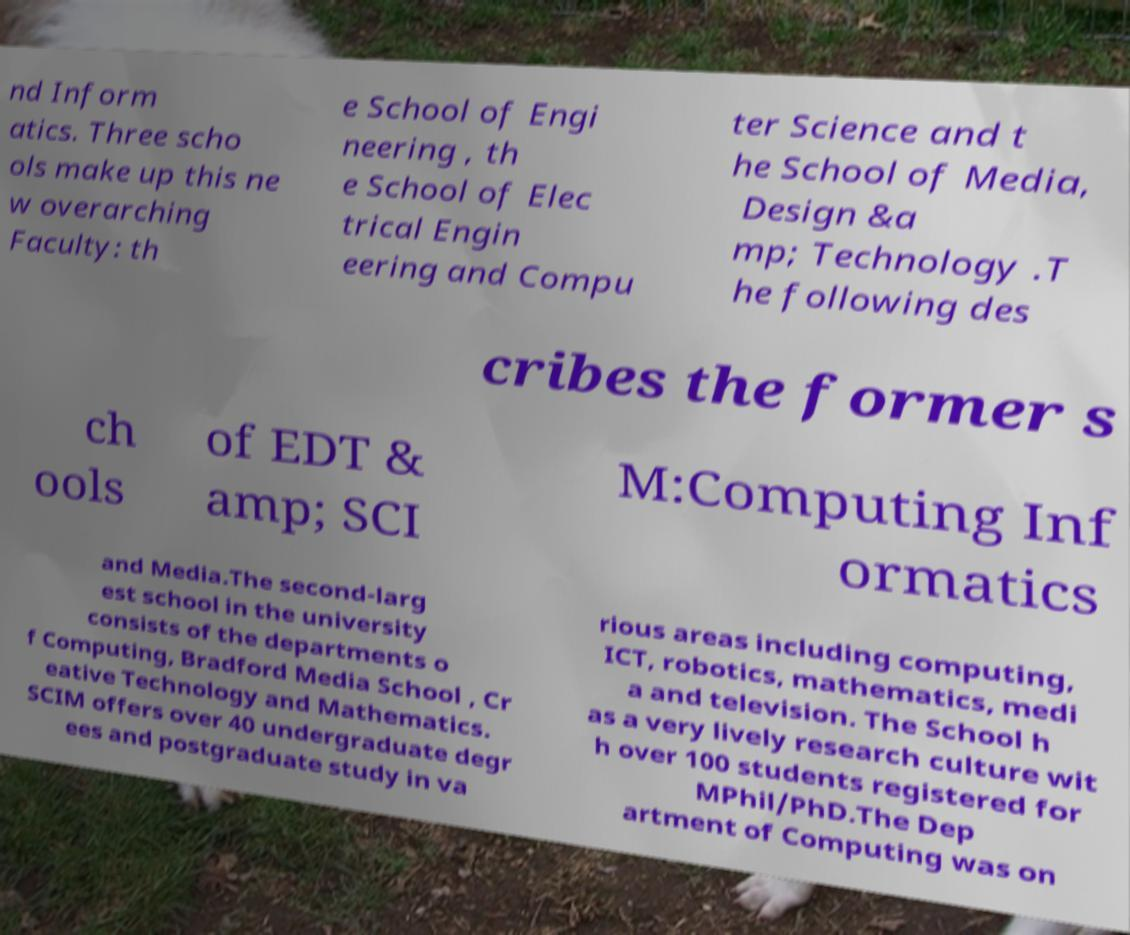Please read and relay the text visible in this image. What does it say? nd Inform atics. Three scho ols make up this ne w overarching Faculty: th e School of Engi neering , th e School of Elec trical Engin eering and Compu ter Science and t he School of Media, Design &a mp; Technology .T he following des cribes the former s ch ools of EDT & amp; SCI M:Computing Inf ormatics and Media.The second-larg est school in the university consists of the departments o f Computing, Bradford Media School , Cr eative Technology and Mathematics. SCIM offers over 40 undergraduate degr ees and postgraduate study in va rious areas including computing, ICT, robotics, mathematics, medi a and television. The School h as a very lively research culture wit h over 100 students registered for MPhil/PhD.The Dep artment of Computing was on 